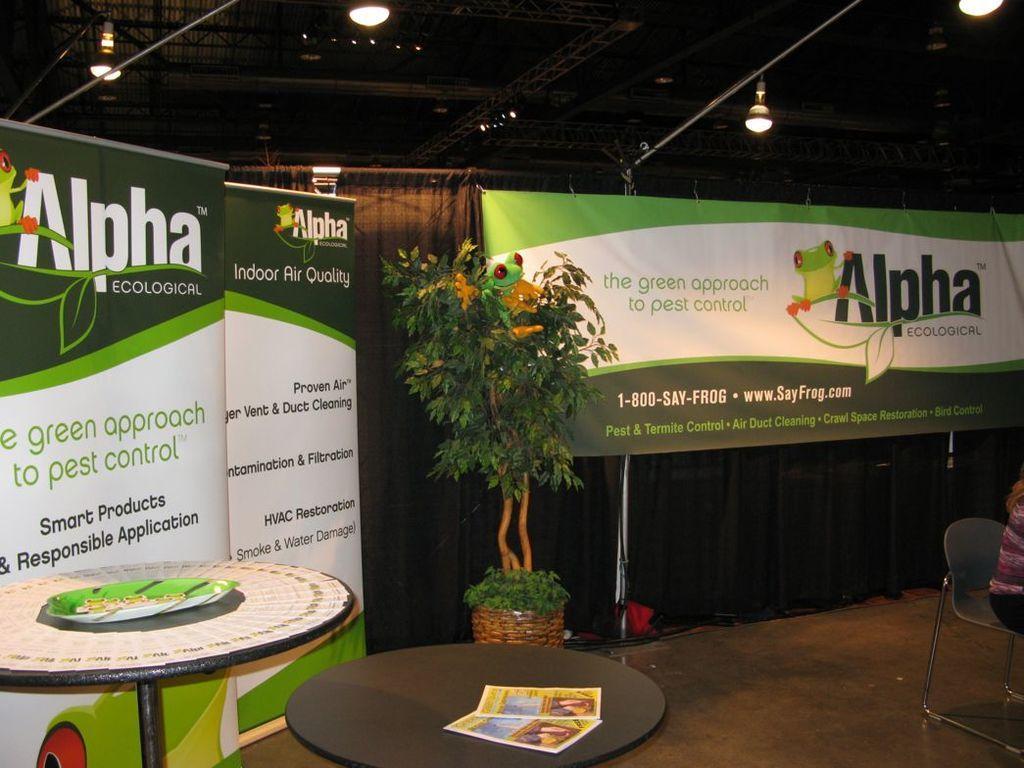Can you describe this image briefly? This picture is inside view of a room. We can see the boards, plants, books, table, plate, lights, roof, rods, curtain, chair and a person is sitting on a chair are present. At the bottom of the image floor is present. 